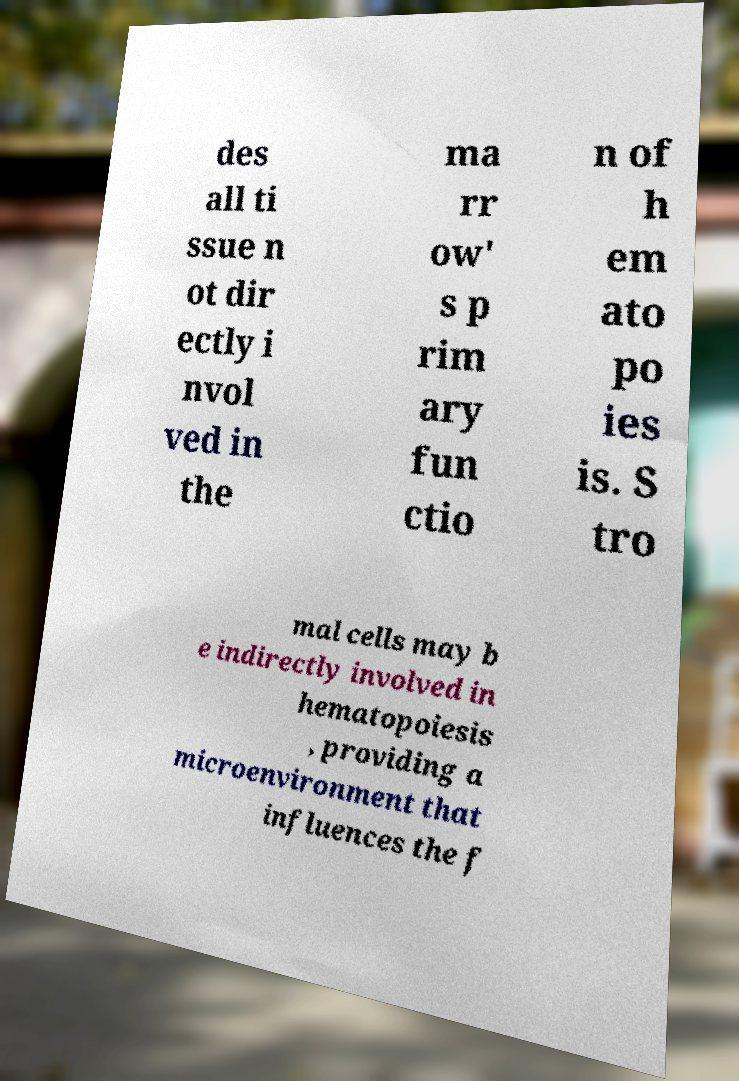What messages or text are displayed in this image? I need them in a readable, typed format. des all ti ssue n ot dir ectly i nvol ved in the ma rr ow' s p rim ary fun ctio n of h em ato po ies is. S tro mal cells may b e indirectly involved in hematopoiesis , providing a microenvironment that influences the f 